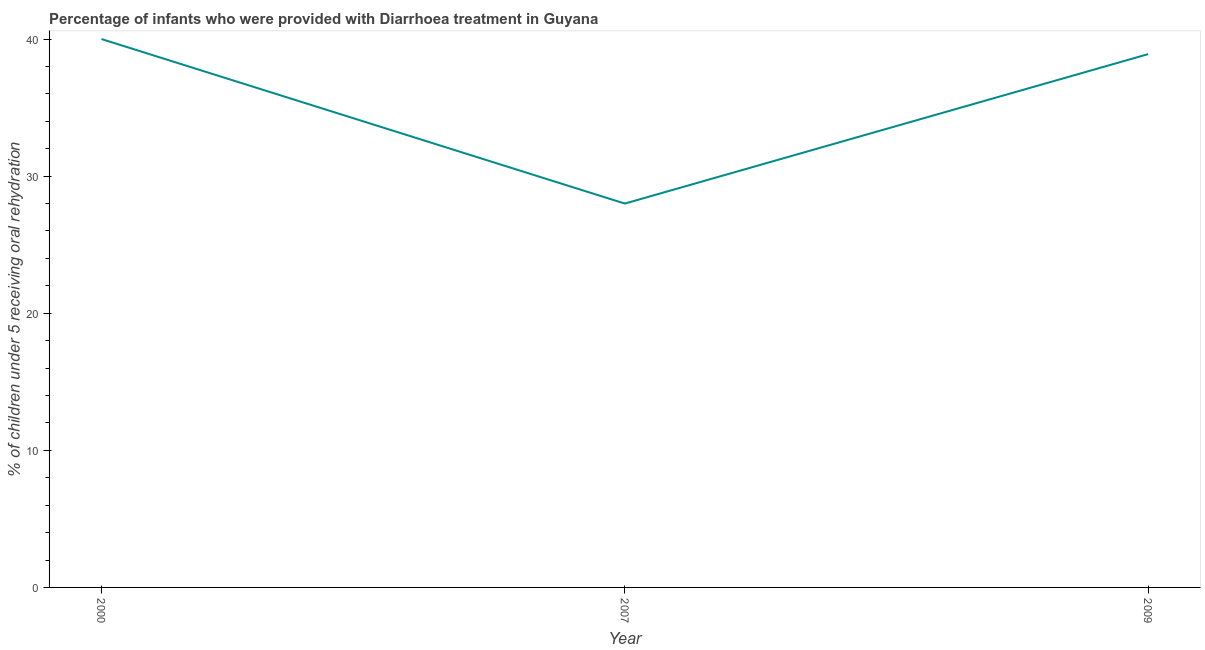What is the percentage of children who were provided with treatment diarrhoea in 2009?
Your response must be concise. 38.9. In which year was the percentage of children who were provided with treatment diarrhoea maximum?
Give a very brief answer. 2000. What is the sum of the percentage of children who were provided with treatment diarrhoea?
Keep it short and to the point. 106.9. What is the average percentage of children who were provided with treatment diarrhoea per year?
Ensure brevity in your answer.  35.63. What is the median percentage of children who were provided with treatment diarrhoea?
Provide a short and direct response. 38.9. In how many years, is the percentage of children who were provided with treatment diarrhoea greater than 22 %?
Offer a very short reply. 3. Do a majority of the years between 2009 and 2000 (inclusive) have percentage of children who were provided with treatment diarrhoea greater than 28 %?
Offer a terse response. No. What is the ratio of the percentage of children who were provided with treatment diarrhoea in 2000 to that in 2009?
Your answer should be compact. 1.03. Is the percentage of children who were provided with treatment diarrhoea in 2000 less than that in 2009?
Your answer should be compact. No. What is the difference between the highest and the second highest percentage of children who were provided with treatment diarrhoea?
Provide a succinct answer. 1.1. How many years are there in the graph?
Offer a very short reply. 3. Does the graph contain any zero values?
Your response must be concise. No. What is the title of the graph?
Ensure brevity in your answer.  Percentage of infants who were provided with Diarrhoea treatment in Guyana. What is the label or title of the X-axis?
Offer a very short reply. Year. What is the label or title of the Y-axis?
Make the answer very short. % of children under 5 receiving oral rehydration. What is the % of children under 5 receiving oral rehydration of 2007?
Offer a very short reply. 28. What is the % of children under 5 receiving oral rehydration in 2009?
Your answer should be compact. 38.9. What is the difference between the % of children under 5 receiving oral rehydration in 2000 and 2009?
Offer a very short reply. 1.1. What is the difference between the % of children under 5 receiving oral rehydration in 2007 and 2009?
Your answer should be compact. -10.9. What is the ratio of the % of children under 5 receiving oral rehydration in 2000 to that in 2007?
Give a very brief answer. 1.43. What is the ratio of the % of children under 5 receiving oral rehydration in 2000 to that in 2009?
Your answer should be very brief. 1.03. What is the ratio of the % of children under 5 receiving oral rehydration in 2007 to that in 2009?
Provide a succinct answer. 0.72. 